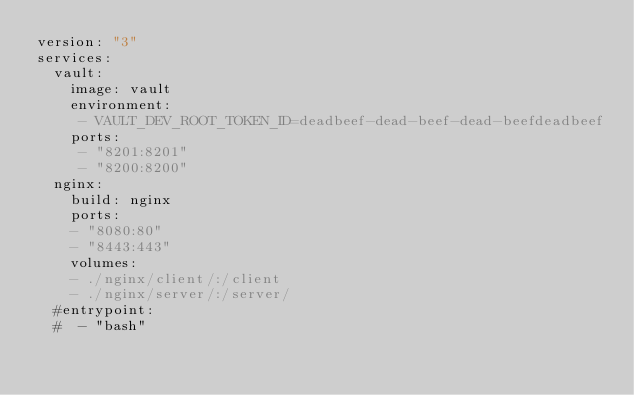<code> <loc_0><loc_0><loc_500><loc_500><_YAML_>version: "3"
services:
  vault:
    image: vault
    environment:
     - VAULT_DEV_ROOT_TOKEN_ID=deadbeef-dead-beef-dead-beefdeadbeef
    ports:
     - "8201:8201"
     - "8200:8200"
  nginx:
    build: nginx
    ports:
    - "8080:80"
    - "8443:443"
    volumes:
    - ./nginx/client/:/client
    - ./nginx/server/:/server/
  #entrypoint:
  #  - "bash"
</code> 